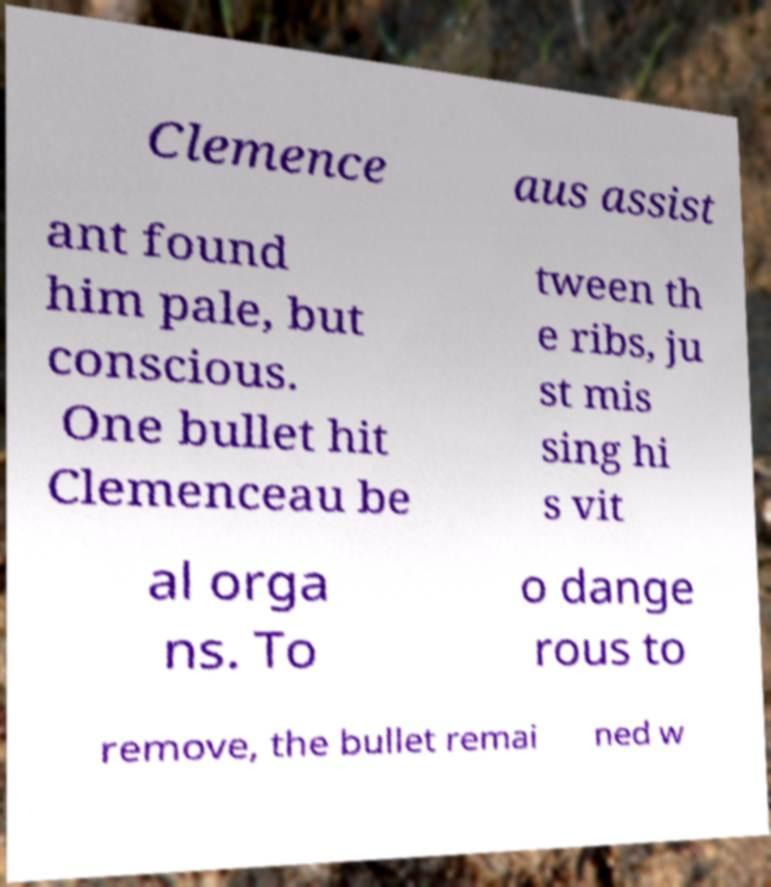There's text embedded in this image that I need extracted. Can you transcribe it verbatim? Clemence aus assist ant found him pale, but conscious. One bullet hit Clemenceau be tween th e ribs, ju st mis sing hi s vit al orga ns. To o dange rous to remove, the bullet remai ned w 